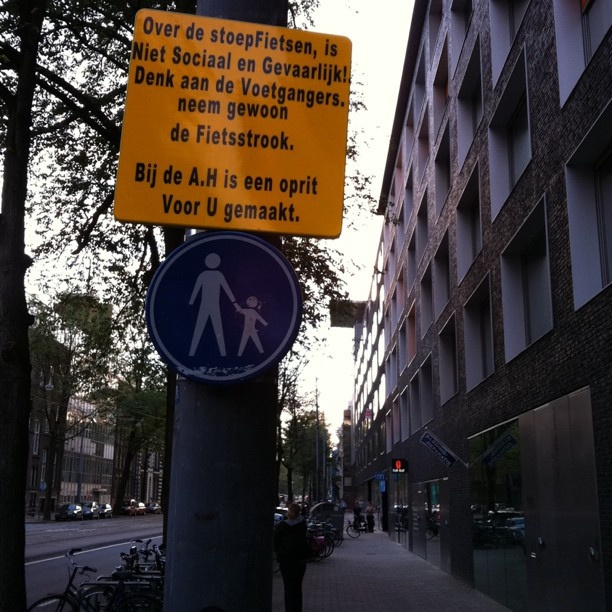Describe the objects in this image and their specific colors. I can see bicycle in darkgray, black, and gray tones, people in black and darkgray tones, bicycle in darkgray, black, and gray tones, bicycle in darkgray, black, gray, and purple tones, and car in darkgray, black, gray, and lightgray tones in this image. 